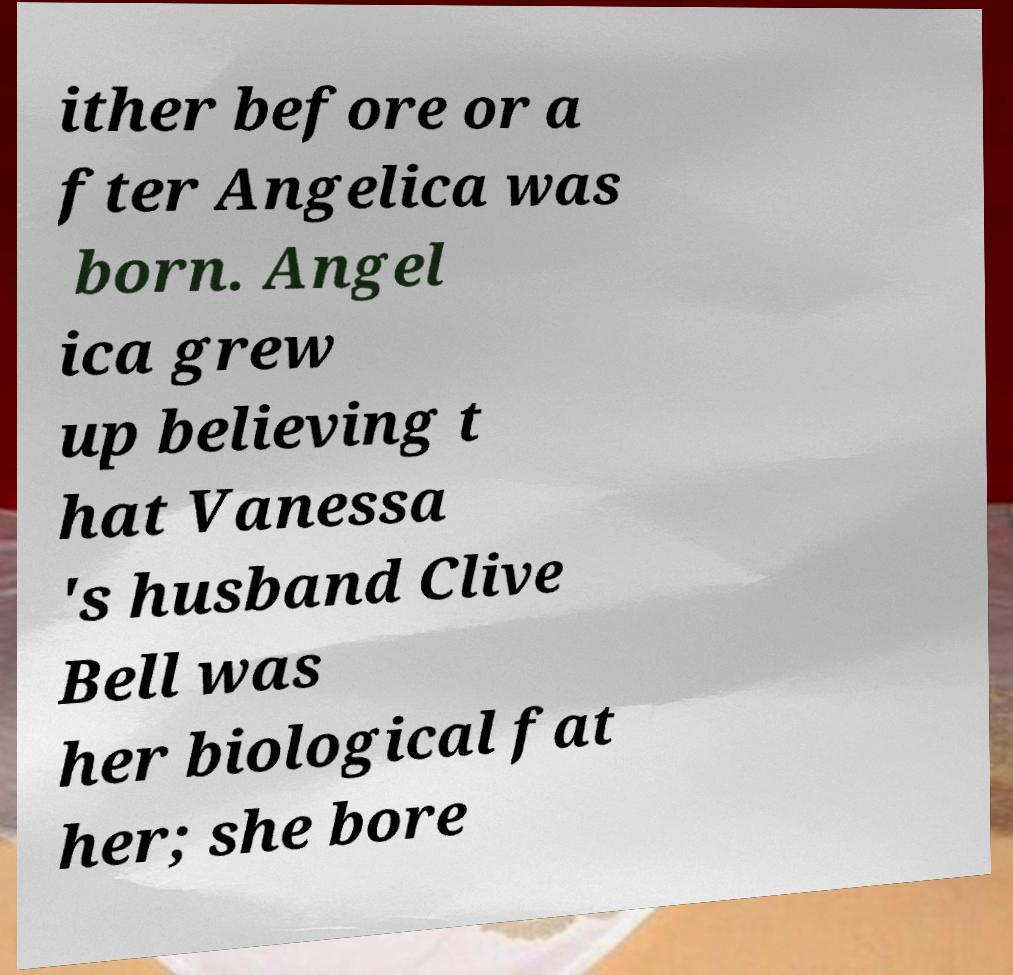Could you extract and type out the text from this image? ither before or a fter Angelica was born. Angel ica grew up believing t hat Vanessa 's husband Clive Bell was her biological fat her; she bore 